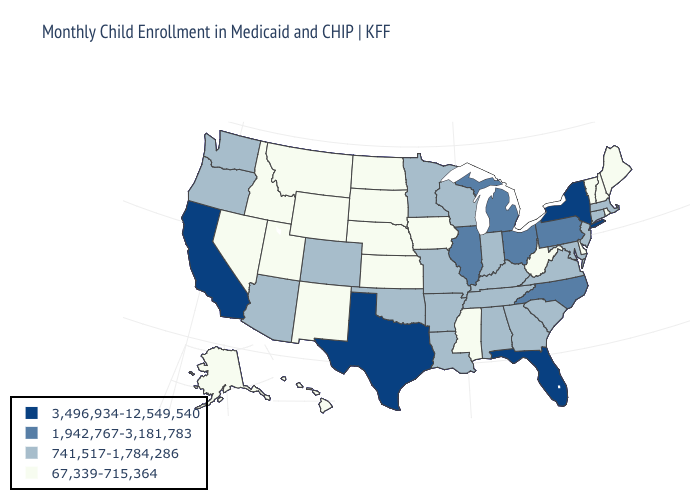What is the highest value in the USA?
Short answer required. 3,496,934-12,549,540. What is the value of North Dakota?
Concise answer only. 67,339-715,364. Name the states that have a value in the range 1,942,767-3,181,783?
Short answer required. Illinois, Michigan, North Carolina, Ohio, Pennsylvania. Which states have the highest value in the USA?
Keep it brief. California, Florida, New York, Texas. What is the highest value in states that border Wyoming?
Concise answer only. 741,517-1,784,286. Name the states that have a value in the range 67,339-715,364?
Answer briefly. Alaska, Delaware, Hawaii, Idaho, Iowa, Kansas, Maine, Mississippi, Montana, Nebraska, Nevada, New Hampshire, New Mexico, North Dakota, Rhode Island, South Dakota, Utah, Vermont, West Virginia, Wyoming. What is the value of Delaware?
Write a very short answer. 67,339-715,364. Which states have the highest value in the USA?
Be succinct. California, Florida, New York, Texas. Does California have the highest value in the West?
Write a very short answer. Yes. What is the lowest value in the West?
Concise answer only. 67,339-715,364. What is the value of Kansas?
Answer briefly. 67,339-715,364. Does Hawaii have a lower value than Alaska?
Give a very brief answer. No. Is the legend a continuous bar?
Keep it brief. No. What is the value of New Jersey?
Answer briefly. 741,517-1,784,286. Does Michigan have the lowest value in the USA?
Give a very brief answer. No. 